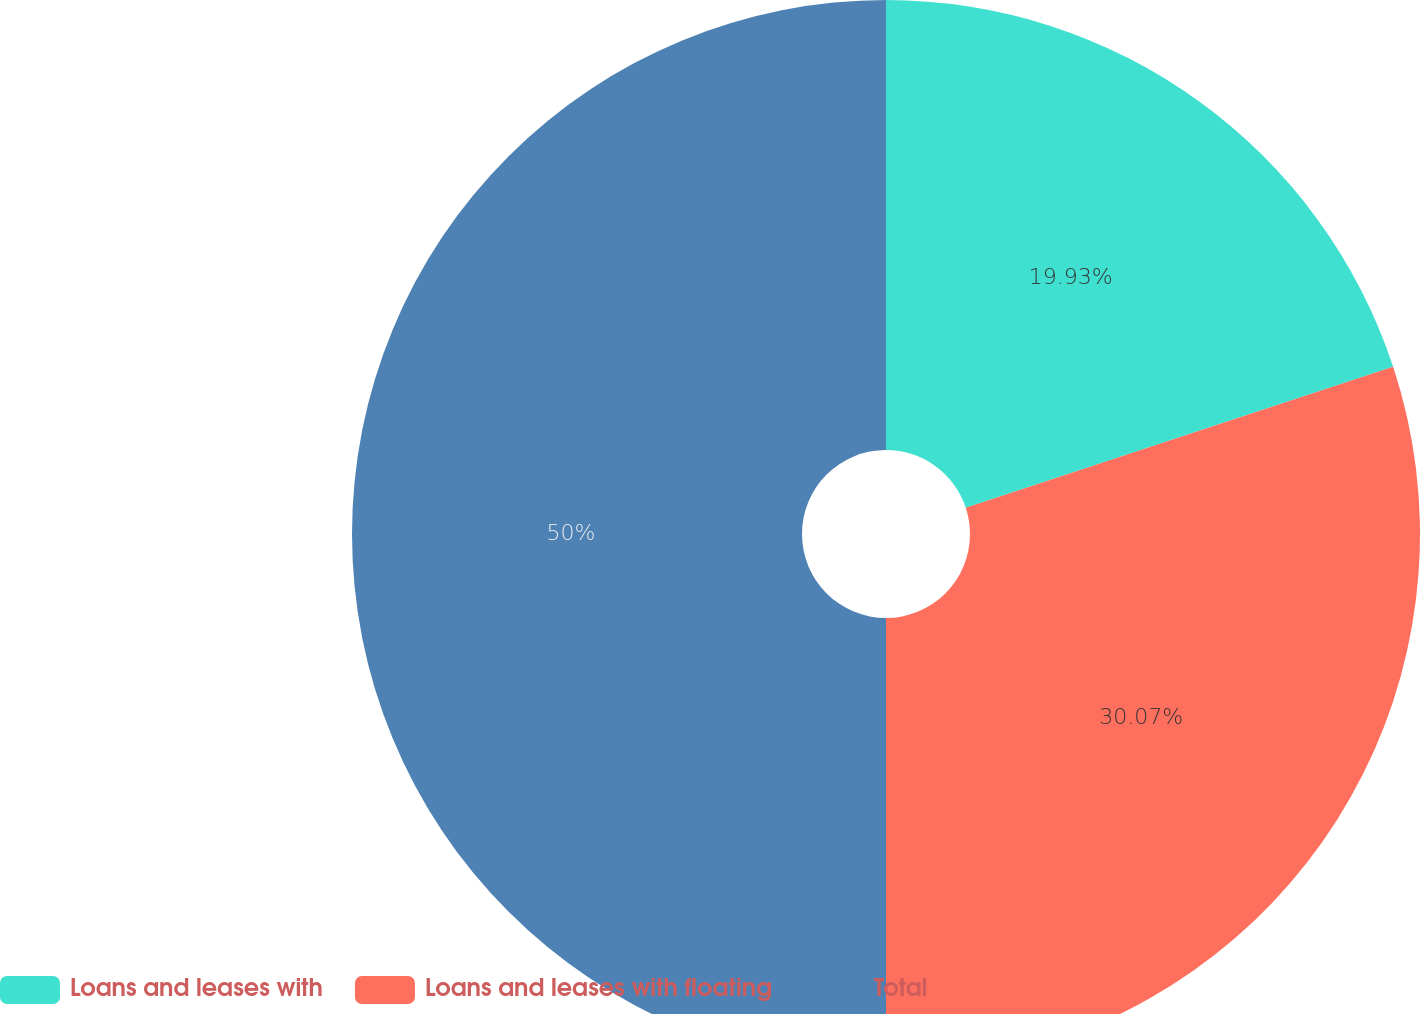Convert chart to OTSL. <chart><loc_0><loc_0><loc_500><loc_500><pie_chart><fcel>Loans and leases with<fcel>Loans and leases with floating<fcel>Total<nl><fcel>19.93%<fcel>30.07%<fcel>50.0%<nl></chart> 